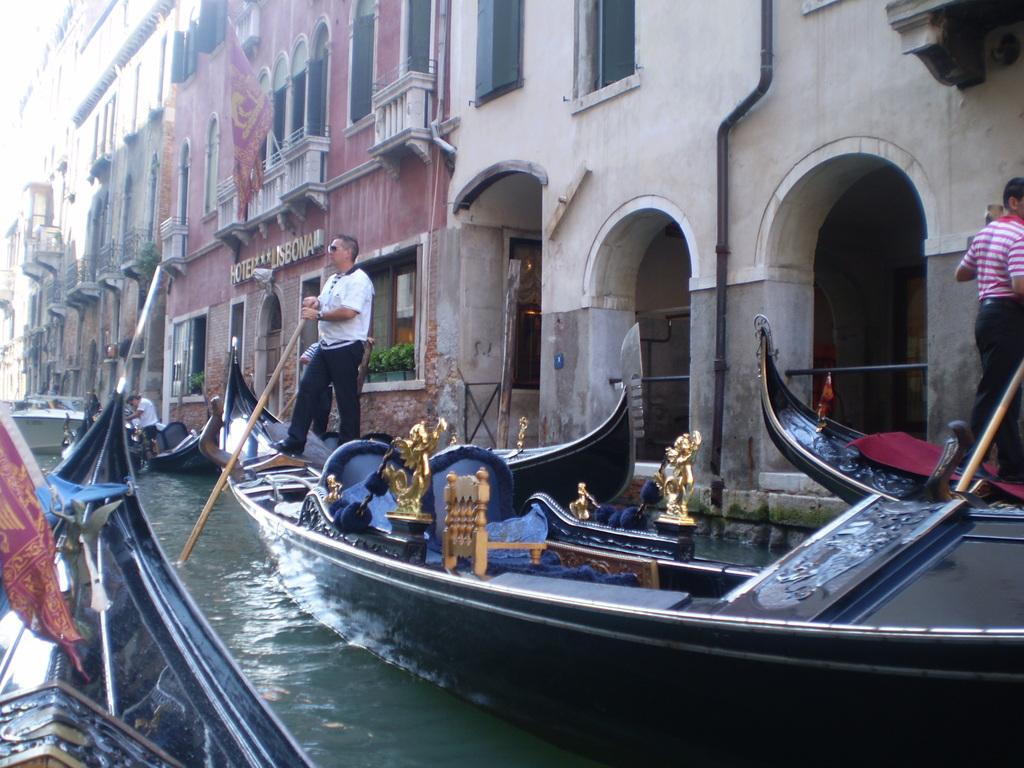What type of structures can be seen in the image? There are buildings in the image. What vehicles are present in the image? There are boats in the image. What natural element is visible in the image? There is water visible in the image. Are there any living beings in the image? Yes, there are people present in the image. Can you tell me how many crackers are floating on the water in the image? There are no crackers present in the image; it features buildings, boats, water, and people. What type of horses can be seen grazing near the buildings in the image? There are no horses present in the image; it only features buildings, boats, water, and people. 